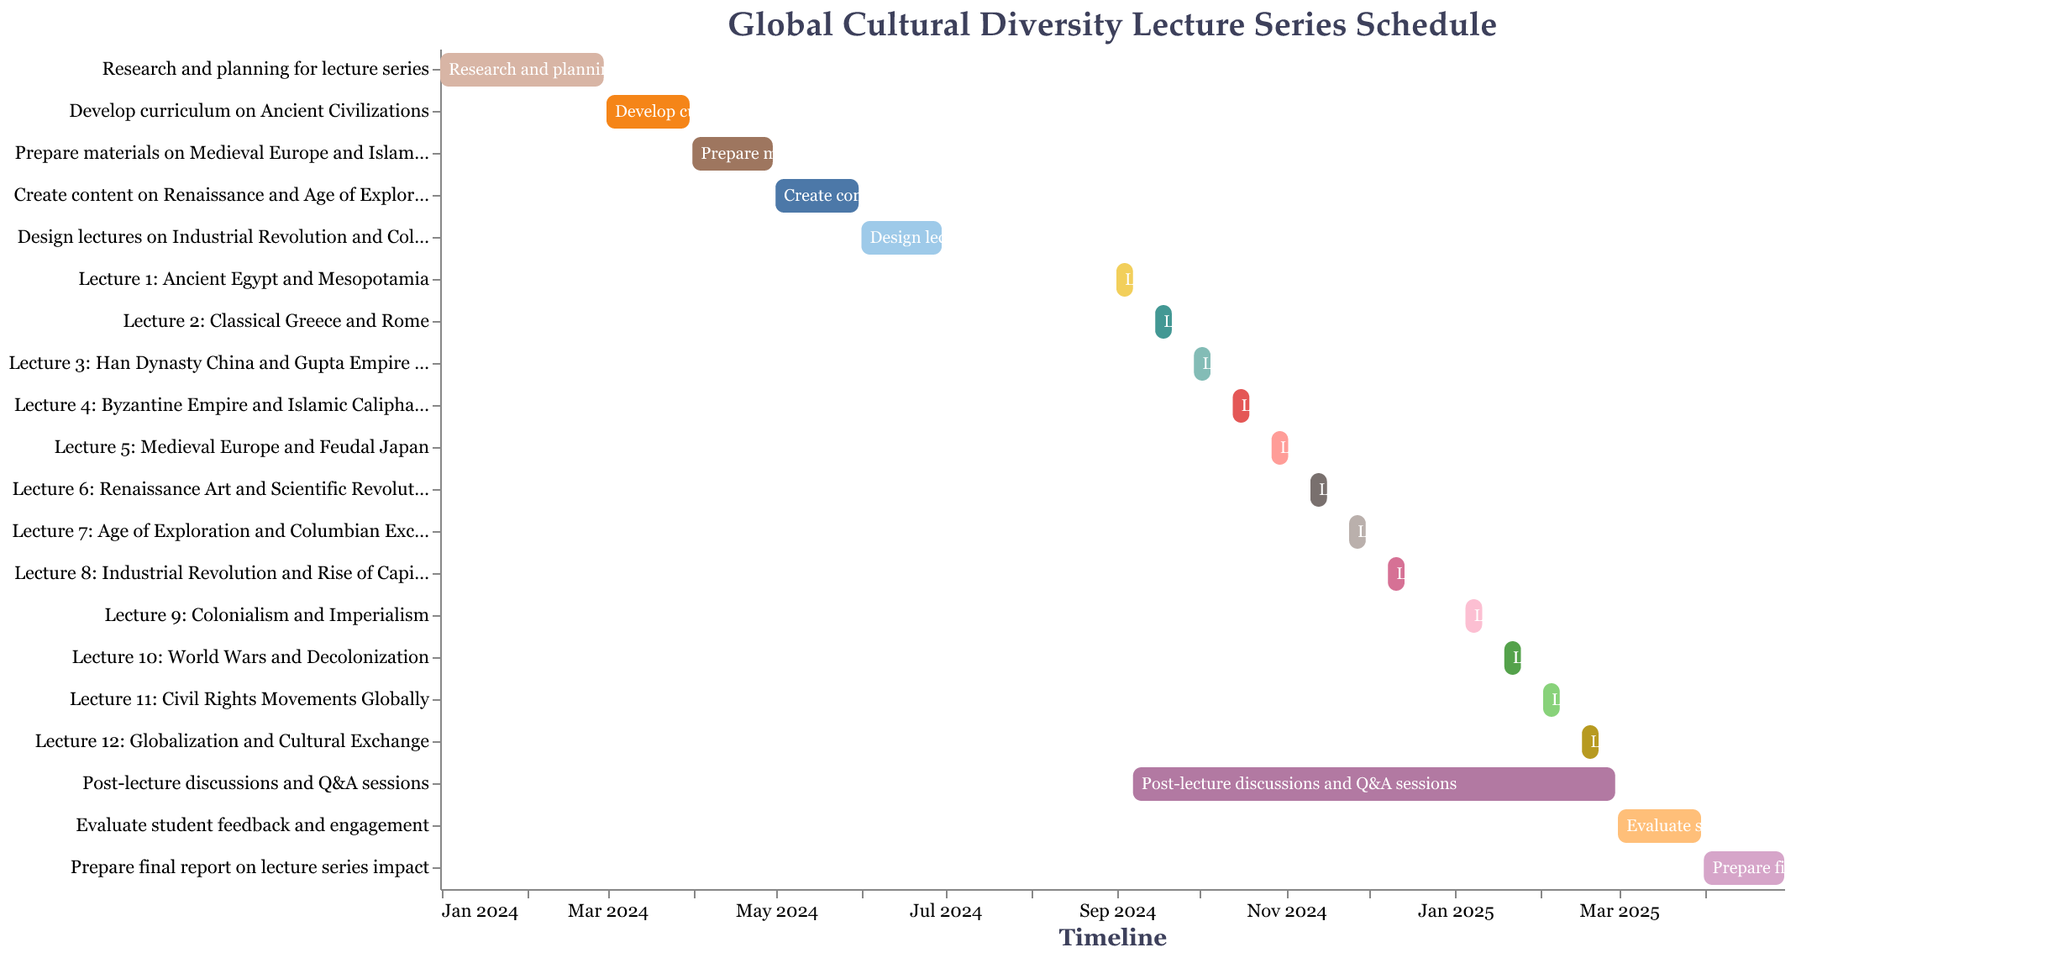How many lectures are included in the series? By counting the lecture tasks labeled with "Lecture" in the figure, we find that there are 12 lectures listed.
Answer: 12 What is the duration of the research and planning phase for the lecture series? The research and planning phase starts on January 1, 2024, and ends on February 29, 2024. Calculating the number of days between these two dates, we get: January has 31 days and February has 29 (since 2024 is a leap year). Therefore, 31 + 29 = 60 days.
Answer: 60 days Between which two tasks is Lecture 6 scheduled? By looking at the timeline, Lecture 6 is scheduled between "Post-lecture discussions and Q&A sessions" and "Lecture 7: Age of Exploration and Columbian Exchange."
Answer: Post-lecture discussions and Q&A sessions and Lecture 7 Which two lectures are held in October 2024? By checking the timelines, lectures held in October are "Lecture 4: Byzantine Empire and Islamic Caliphates" (October 13–19) and "Lecture 5: Medieval Europe and Feudal Japan" (October 27–November 2).
Answer: Lecture 4 and Lecture 5 What is the last preparation task before the first lecture starts? The first lecture, "Lecture 1: Ancient Egypt and Mesopotamia," starts on September 1, 2024. The preparation task before this is "Design lectures on Industrial Revolution and Colonialism," ending on June 30, 2024.
Answer: Design lectures on Industrial Revolution and Colonialism How long is the gap between Lecture 2 and Lecture 3? Lecture 2 ends on September 21, 2024, and Lecture 3 starts on September 29, 2024. Calculating the difference between these dates, we get 8 days.
Answer: 8 days Compare the duration of "Evaluate student feedback and engagement" with "Prepare final report on lecture series impact." Which one takes longer? "Evaluate student feedback and engagement" runs from March 1 to March 31, 2025, totaling 31 days. "Prepare final report on lecture series impact" runs from April 1 to April 30, 2025, also totaling 30 days. Therefore, "Evaluate student feedback and engagement" takes 1 day longer.
Answer: Evaluate student feedback and engagement When does the "Post-lecture discussions and Q&A sessions" period overlap with the lectures? The "Post-lecture discussions and Q&A sessions" period overlaps the lectures from September 7, 2024, to February 28, 2025, since both activities run concurrently during the entire lecture series.
Answer: September 7, 2024, to February 28, 2025 